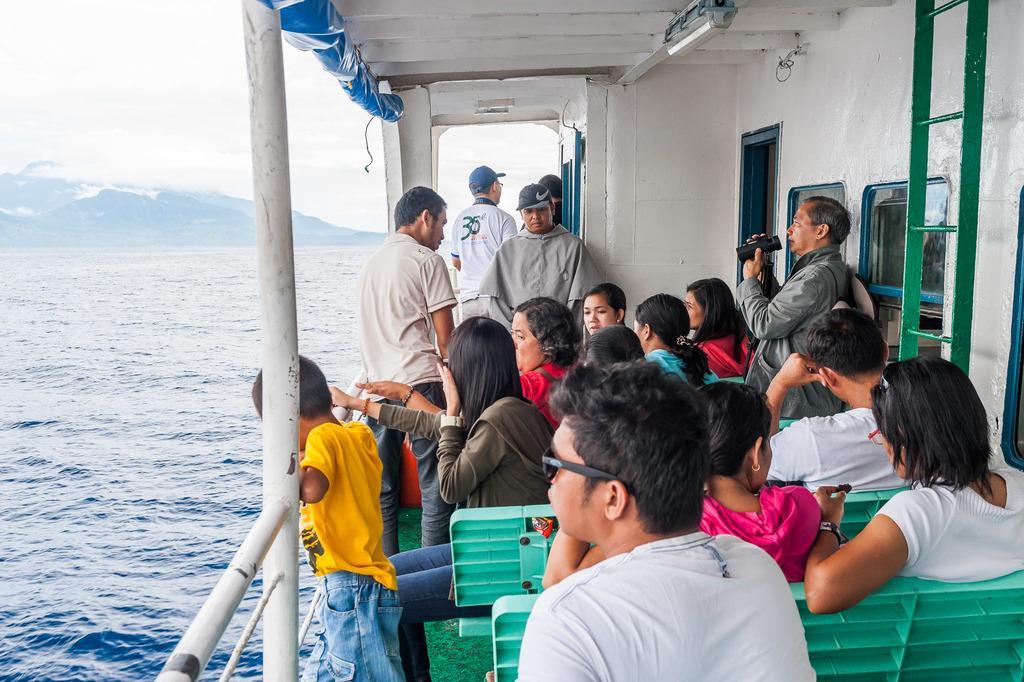In one or two sentences, can you explain what this image depicts? In the picture I can see a group of people sitting on the bench and they are in the ship. I can see a man on the right side and he is holding a bio-scope in his hands. There is a boy on the left side is wearing a yellow color T-shirt and he is having a look at the water. In the background, I can see the mountains. There are clouds in the sky. 